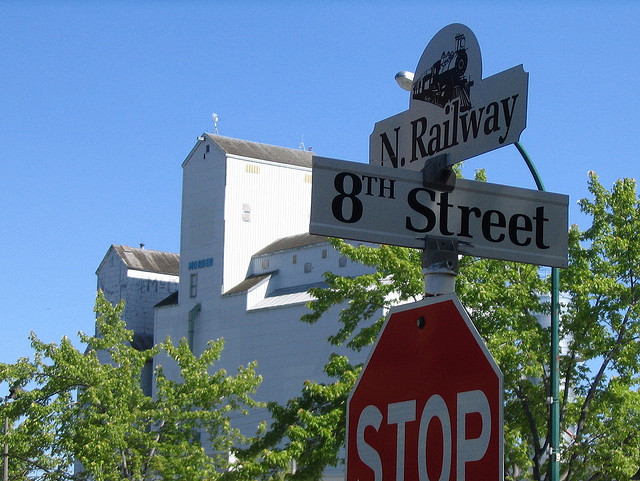Identify the text contained in this image. N Railway 8TH Street STOP 